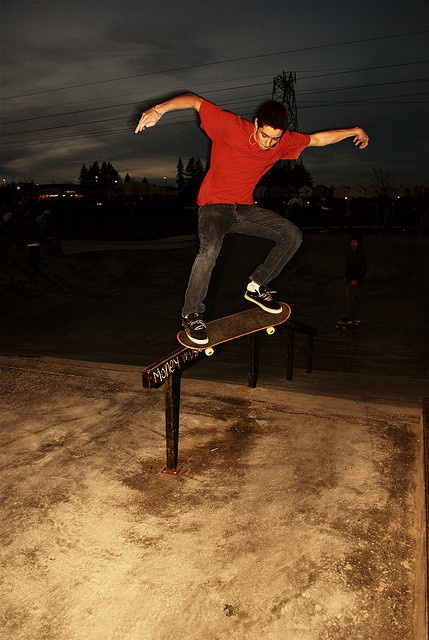Describe the objects in this image and their specific colors. I can see people in black, brown, and maroon tones, skateboard in black, maroon, brown, and orange tones, and people in black and maroon tones in this image. 